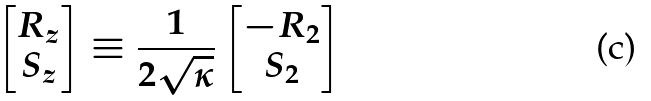<formula> <loc_0><loc_0><loc_500><loc_500>\begin{bmatrix} R _ { z } \\ S _ { z } \end{bmatrix} \equiv \frac { 1 } { 2 \sqrt { \kappa } } \begin{bmatrix} - R _ { 2 } \\ S _ { 2 } \end{bmatrix}</formula> 